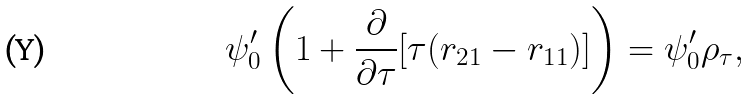Convert formula to latex. <formula><loc_0><loc_0><loc_500><loc_500>\psi ^ { \prime } _ { 0 } \left ( 1 + \frac { \partial } { \partial \tau } [ \tau ( r _ { 2 1 } - r _ { 1 1 } ) ] \right ) = \psi ^ { \prime } _ { 0 } \rho _ { \tau } ,</formula> 